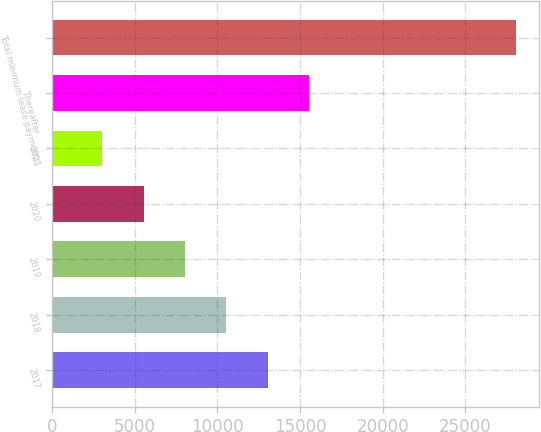Convert chart. <chart><loc_0><loc_0><loc_500><loc_500><bar_chart><fcel>2017<fcel>2018<fcel>2019<fcel>2020<fcel>2021<fcel>Thereafter<fcel>Total minimum lease payments<nl><fcel>13027<fcel>10526<fcel>8025<fcel>5524<fcel>3023<fcel>15528<fcel>28033<nl></chart> 